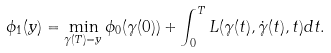<formula> <loc_0><loc_0><loc_500><loc_500>\phi _ { 1 } ( y ) = \min _ { \gamma ( T ) = y } \phi _ { 0 } ( \gamma ( 0 ) ) + \int _ { 0 } ^ { T } L ( \gamma ( t ) , \dot { \gamma } ( t ) , t ) d t .</formula> 